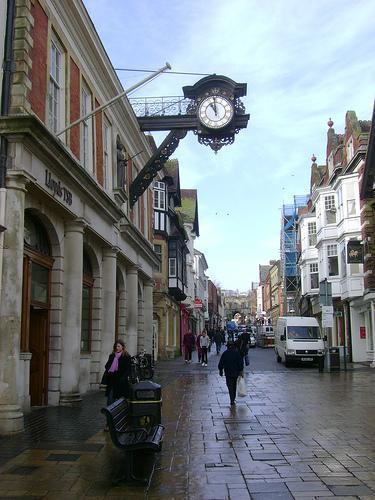How many clocks are there?
Give a very brief answer. 1. 